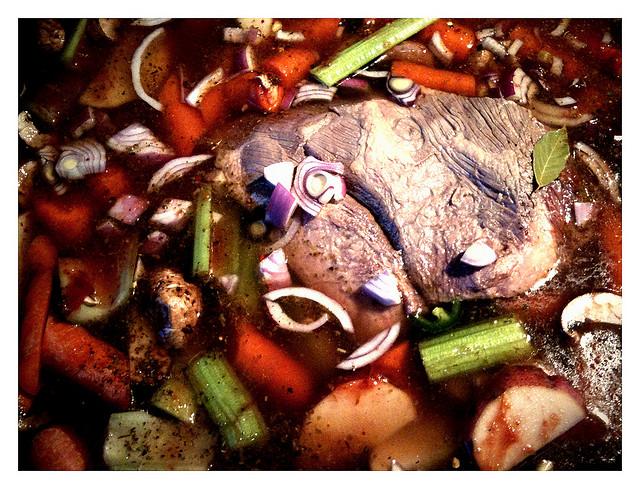What are the green things?
Quick response, please. Celery. Is the food likely cold or hot?
Be succinct. Hot. What type of meat is being boiled?
Be succinct. Beef. 